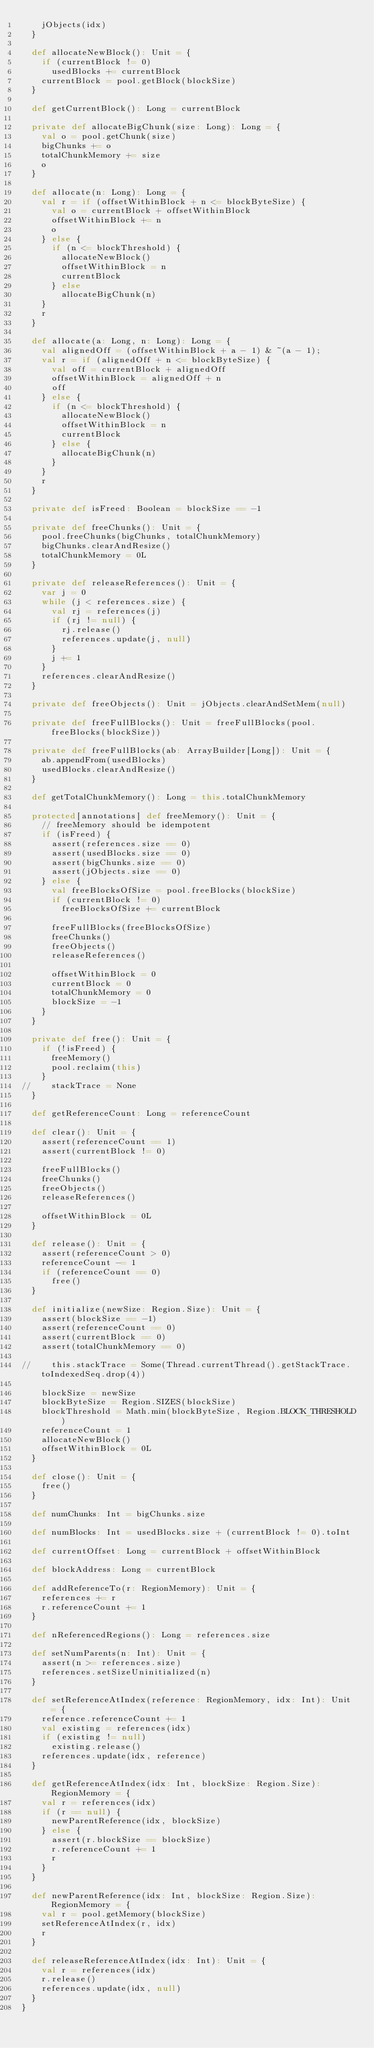<code> <loc_0><loc_0><loc_500><loc_500><_Scala_>    jObjects(idx)
  }

  def allocateNewBlock(): Unit = {
    if (currentBlock != 0)
      usedBlocks += currentBlock
    currentBlock = pool.getBlock(blockSize)
  }

  def getCurrentBlock(): Long = currentBlock

  private def allocateBigChunk(size: Long): Long = {
    val o = pool.getChunk(size)
    bigChunks += o
    totalChunkMemory += size
    o
  }

  def allocate(n: Long): Long = {
    val r = if (offsetWithinBlock + n <= blockByteSize) {
      val o = currentBlock + offsetWithinBlock
      offsetWithinBlock += n
      o
    } else {
      if (n <= blockThreshold) {
        allocateNewBlock()
        offsetWithinBlock = n
        currentBlock
      } else
        allocateBigChunk(n)
    }
    r
  }

  def allocate(a: Long, n: Long): Long = {
    val alignedOff = (offsetWithinBlock + a - 1) & ~(a - 1);
    val r = if (alignedOff + n <= blockByteSize) {
      val off = currentBlock + alignedOff
      offsetWithinBlock = alignedOff + n
      off
    } else {
      if (n <= blockThreshold) {
        allocateNewBlock()
        offsetWithinBlock = n
        currentBlock
      } else {
        allocateBigChunk(n)
      }
    }
    r
  }

  private def isFreed: Boolean = blockSize == -1

  private def freeChunks(): Unit = {
    pool.freeChunks(bigChunks, totalChunkMemory)
    bigChunks.clearAndResize()
    totalChunkMemory = 0L
  }

  private def releaseReferences(): Unit = {
    var j = 0
    while (j < references.size) {
      val rj = references(j)
      if (rj != null) {
        rj.release()
        references.update(j, null)
      }
      j += 1
    }
    references.clearAndResize()
  }

  private def freeObjects(): Unit = jObjects.clearAndSetMem(null)

  private def freeFullBlocks(): Unit = freeFullBlocks(pool.freeBlocks(blockSize))

  private def freeFullBlocks(ab: ArrayBuilder[Long]): Unit = {
    ab.appendFrom(usedBlocks)
    usedBlocks.clearAndResize()
  }

  def getTotalChunkMemory(): Long = this.totalChunkMemory

  protected[annotations] def freeMemory(): Unit = {
    // freeMemory should be idempotent
    if (isFreed) {
      assert(references.size == 0)
      assert(usedBlocks.size == 0)
      assert(bigChunks.size == 0)
      assert(jObjects.size == 0)
    } else {
      val freeBlocksOfSize = pool.freeBlocks(blockSize)
      if (currentBlock != 0)
        freeBlocksOfSize += currentBlock

      freeFullBlocks(freeBlocksOfSize)
      freeChunks()
      freeObjects()
      releaseReferences()

      offsetWithinBlock = 0
      currentBlock = 0
      totalChunkMemory = 0
      blockSize = -1
    }
  }

  private def free(): Unit = {
    if (!isFreed) {
      freeMemory()
      pool.reclaim(this)
    }
//    stackTrace = None
  }

  def getReferenceCount: Long = referenceCount

  def clear(): Unit = {
    assert(referenceCount == 1)
    assert(currentBlock != 0)

    freeFullBlocks()
    freeChunks()
    freeObjects()
    releaseReferences()

    offsetWithinBlock = 0L
  }

  def release(): Unit = {
    assert(referenceCount > 0)
    referenceCount -= 1
    if (referenceCount == 0)
      free()
  }

  def initialize(newSize: Region.Size): Unit = {
    assert(blockSize == -1)
    assert(referenceCount == 0)
    assert(currentBlock == 0)
    assert(totalChunkMemory == 0)

//    this.stackTrace = Some(Thread.currentThread().getStackTrace.toIndexedSeq.drop(4))

    blockSize = newSize
    blockByteSize = Region.SIZES(blockSize)
    blockThreshold = Math.min(blockByteSize, Region.BLOCK_THRESHOLD)
    referenceCount = 1
    allocateNewBlock()
    offsetWithinBlock = 0L
  }

  def close(): Unit = {
    free()
  }

  def numChunks: Int = bigChunks.size

  def numBlocks: Int = usedBlocks.size + (currentBlock != 0).toInt

  def currentOffset: Long = currentBlock + offsetWithinBlock

  def blockAddress: Long = currentBlock

  def addReferenceTo(r: RegionMemory): Unit = {
    references += r
    r.referenceCount += 1
  }

  def nReferencedRegions(): Long = references.size

  def setNumParents(n: Int): Unit = {
    assert(n >= references.size)
    references.setSizeUninitialized(n)
  }

  def setReferenceAtIndex(reference: RegionMemory, idx: Int): Unit = {
    reference.referenceCount += 1
    val existing = references(idx)
    if (existing != null)
      existing.release()
    references.update(idx, reference)
  }

  def getReferenceAtIndex(idx: Int, blockSize: Region.Size): RegionMemory = {
    val r = references(idx)
    if (r == null) {
      newParentReference(idx, blockSize)
    } else {
      assert(r.blockSize == blockSize)
      r.referenceCount += 1
      r
    }
  }

  def newParentReference(idx: Int, blockSize: Region.Size): RegionMemory = {
    val r = pool.getMemory(blockSize)
    setReferenceAtIndex(r, idx)
    r
  }

  def releaseReferenceAtIndex(idx: Int): Unit = {
    val r = references(idx)
    r.release()
    references.update(idx, null)
  }
}
</code> 